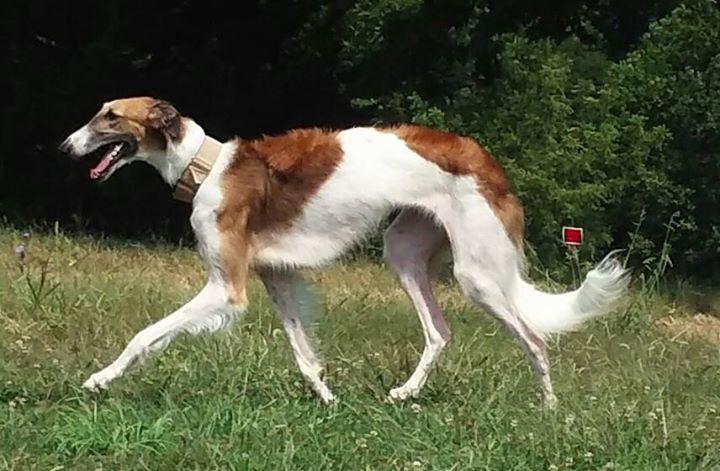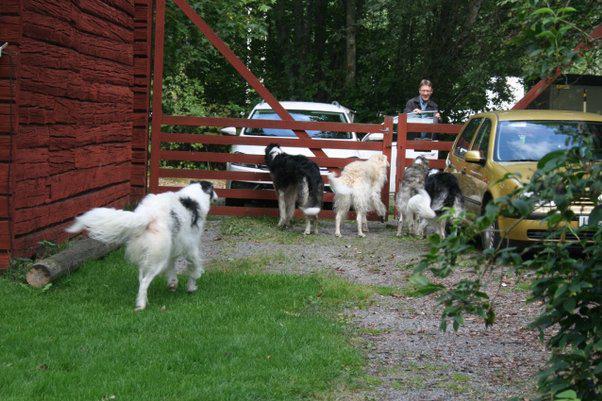The first image is the image on the left, the second image is the image on the right. Examine the images to the left and right. Is the description "A person is training a long haired dog." accurate? Answer yes or no. No. The first image is the image on the left, the second image is the image on the right. For the images displayed, is the sentence "In at least one image there is a woman whose body is facing left  while showing a tall dog with some white fur." factually correct? Answer yes or no. No. 